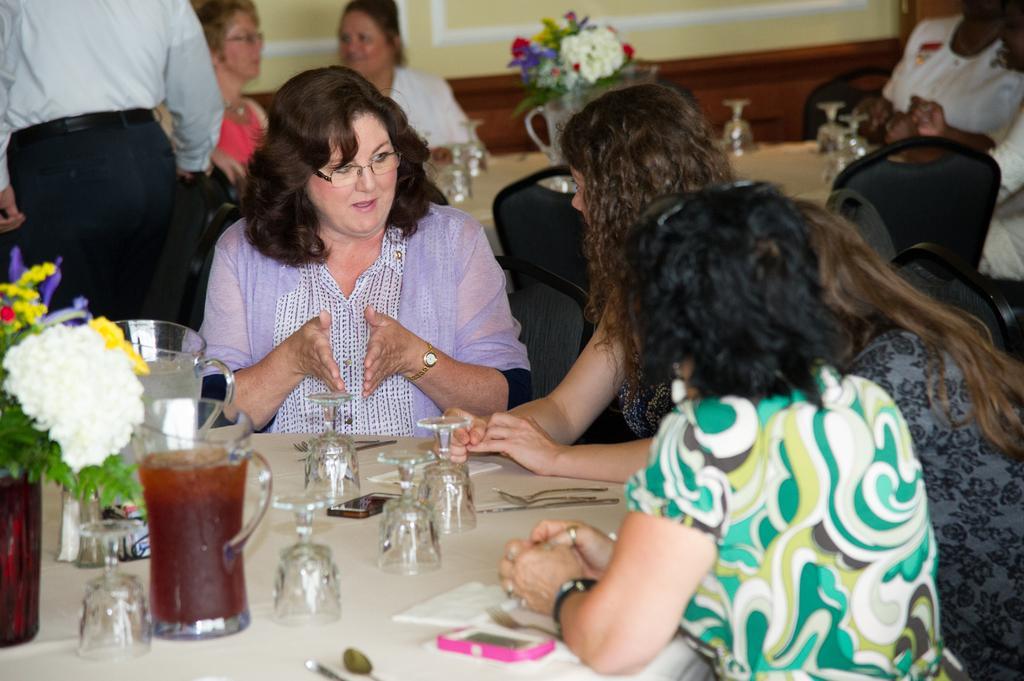Can you describe this image briefly? In the image we can see there are people who are sitting on chair and on table there are wine glass and in jug there is juice, there is mobile phones, spoon, fork and vase in which there are flowers and other people are standing and sitting at the back. 